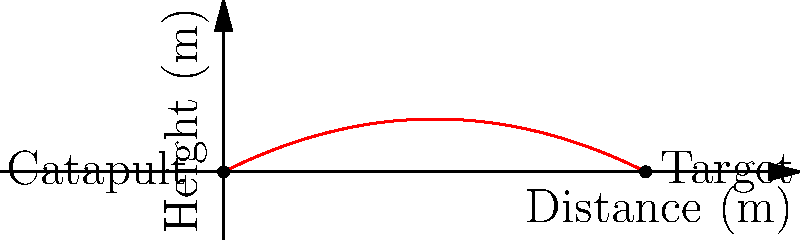In your historical wargame scenario, a catapult launches a projectile with an initial velocity of 10 m/s at an angle of 30° from the horizontal. The trajectory of the projectile can be modeled by the function $h(x) = -0.025x^2 + 0.5x$, where $h$ is the height in meters and $x$ is the horizontal distance in meters. What is the maximum height reached by the projectile? To find the maximum height of the projectile, we need to follow these steps:

1) The maximum height occurs at the vertex of the parabola described by $h(x) = -0.025x^2 + 0.5x$.

2) For a quadratic function in the form $f(x) = ax^2 + bx + c$, the x-coordinate of the vertex is given by $x = -\frac{b}{2a}$.

3) In our case, $a = -0.025$ and $b = 0.5$. Let's call the x-coordinate of the vertex $x_v$.

4) $x_v = -\frac{0.5}{2(-0.025)} = -\frac{0.5}{-0.05} = 10$ meters

5) To find the maximum height, we need to plug this x-value back into our original function:

   $h(10) = -0.025(10)^2 + 0.5(10)$
   
   $= -0.025(100) + 5$
   
   $= -2.5 + 5 = 2.5$ meters

Therefore, the maximum height reached by the projectile is 2.5 meters.
Answer: 2.5 meters 